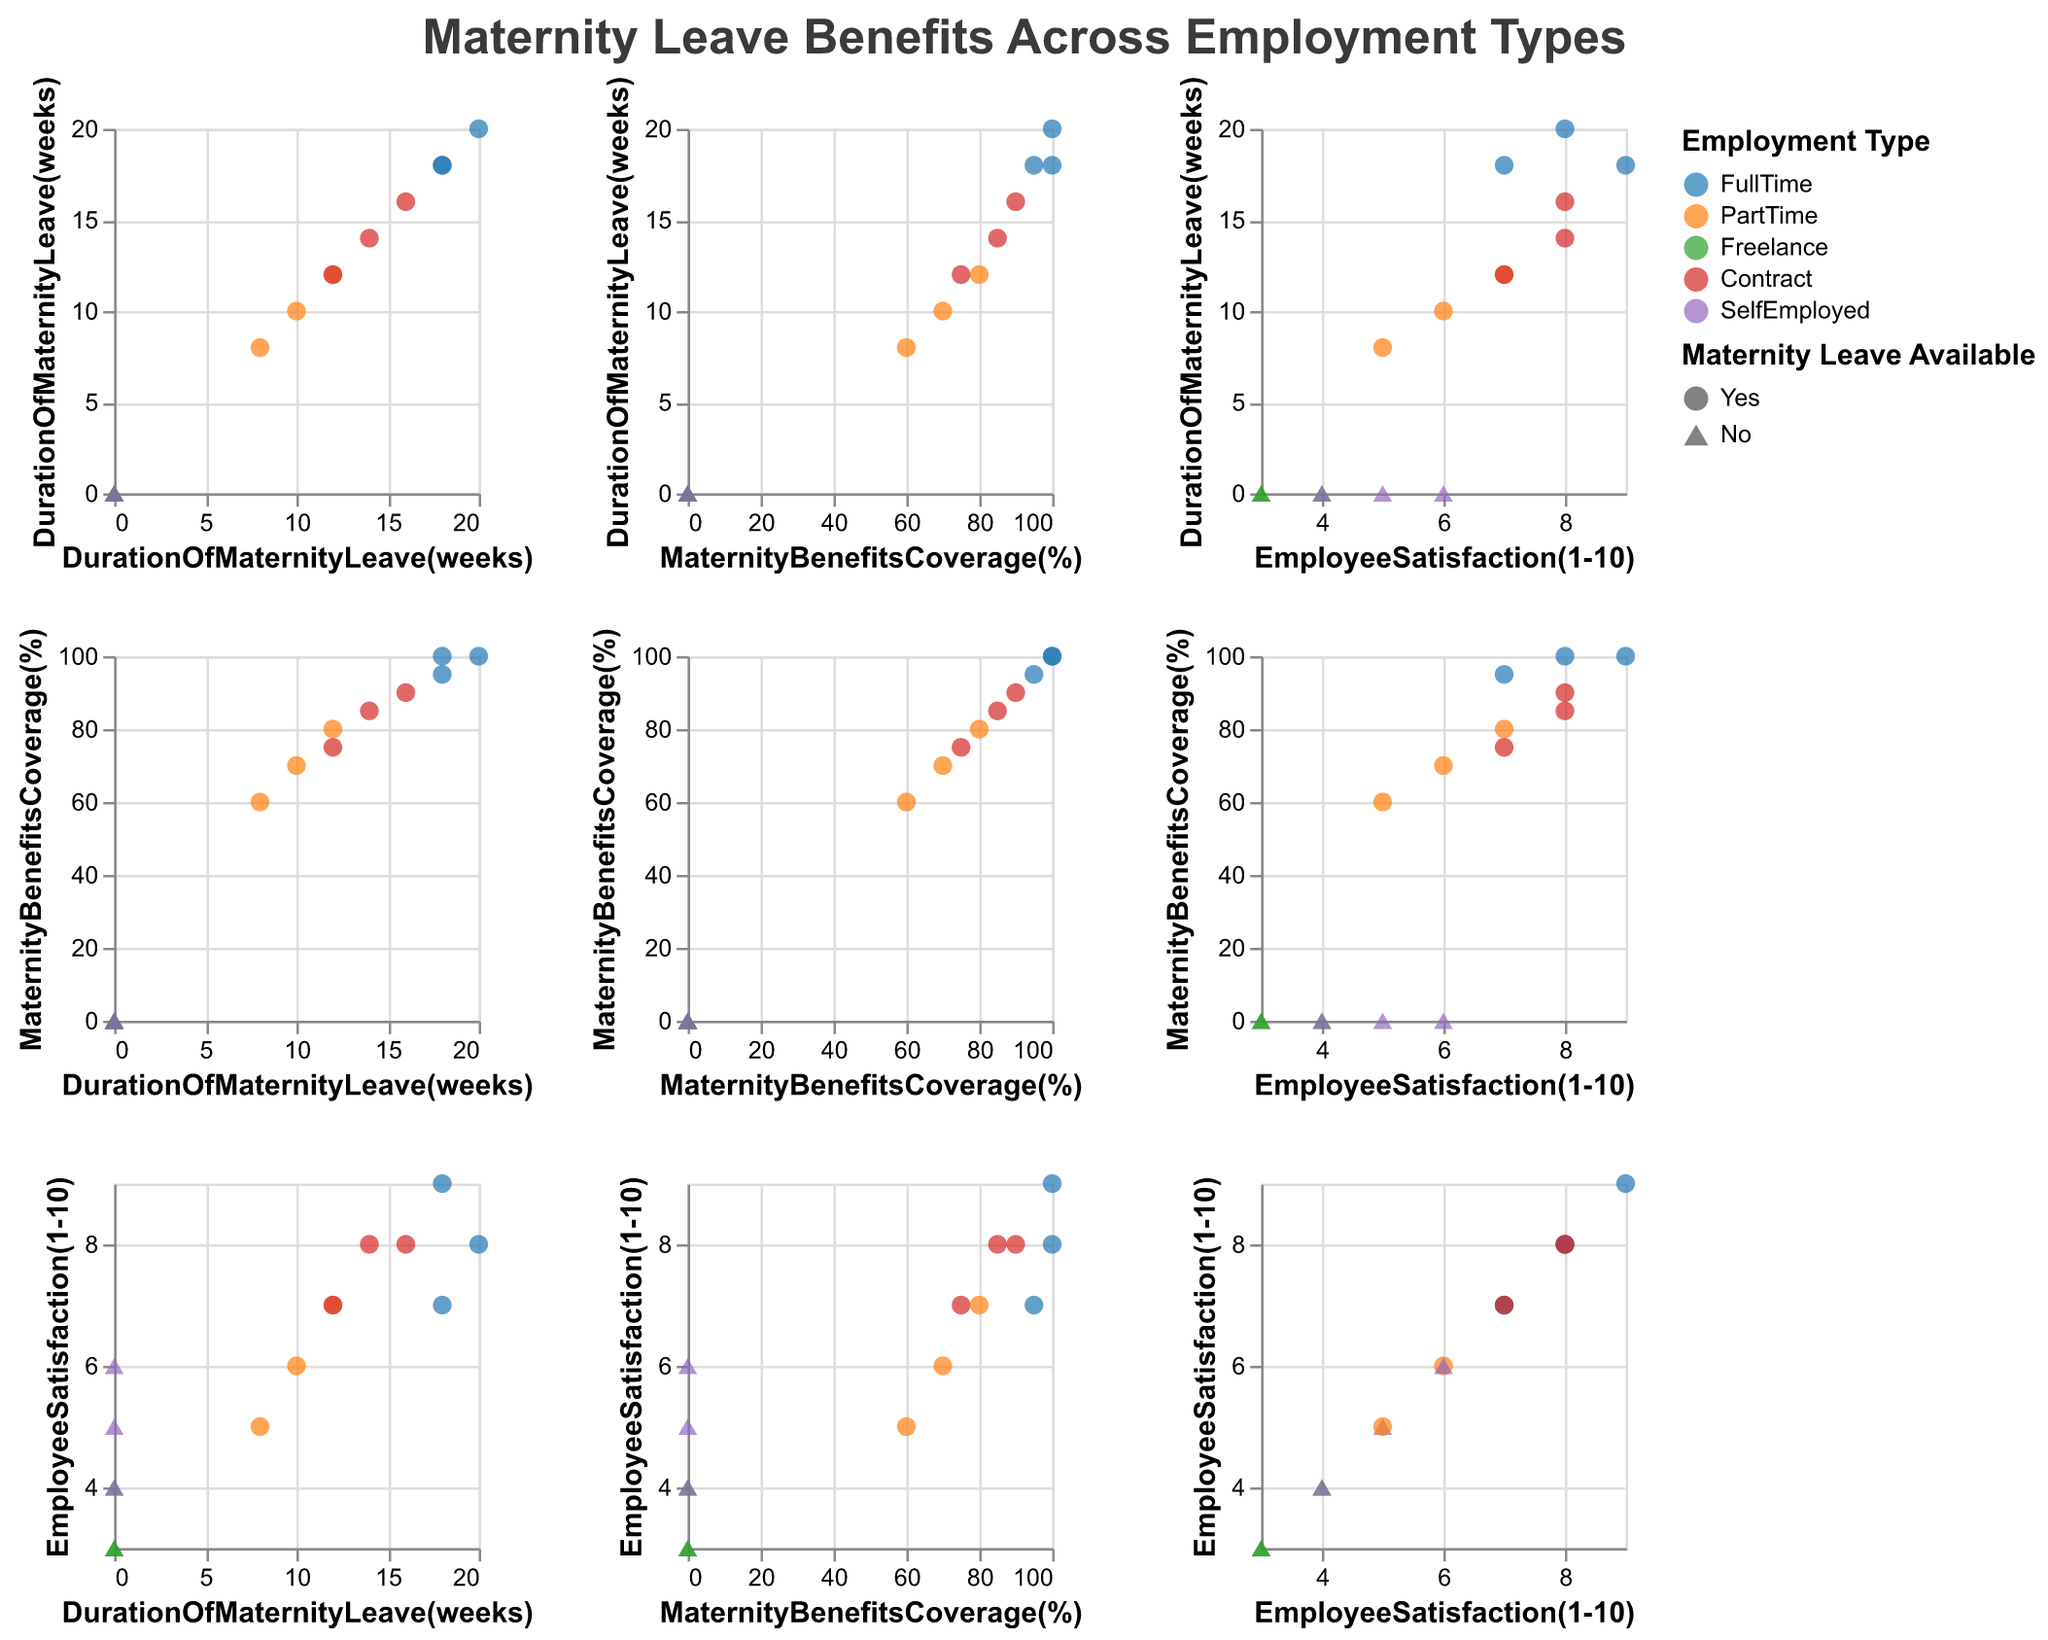What is the title of the figure? The title of the figure is displayed at the top and reads "Maternity Leave Benefits Across Employment Types".
Answer: Maternity Leave Benefits Across Employment Types Which employment type has the least availability of maternity leave? By looking at the shapes in the plot, triangles indicate the unavailability of maternity leave. Freelance and SelfEmployed both show only triangles.
Answer: Freelance and SelfEmployed What shape is used to indicate the availability of maternity leave? In the figure, a legend shows that circles indicate 'Yes' for availability of maternity leave.
Answer: Circle How many companies offer 100% maternity benefits coverage? By counting the data points at 100% on the y-axis "MaternityBenefitsCoverage(%)", there are two companies.
Answer: 2 Which company offers the longest duration of maternity leave? Identify the highest value on the "DurationOfMaternityLeave(weeks)" axis and check the tooltip for the company name. Amazon offers 20 weeks of maternity leave.
Answer: Amazon Is there a correlation between the duration of maternity leave and employee satisfaction? Look for any pattern in the scatter plots where "DurationOfMaternityLeave(weeks)" is on one axis and "EmployeeSatisfaction(1-10)" is on the other. Higher durations typically show higher satisfaction.
Answer: Generally positive correlation For full-time employees, what is the range of maternity benefits coverage? By focusing on the color representing "FullTime" (blue) and the y-axis "MaternityBenefitsCoverage(%)", the range spans from about 95% to 100%.
Answer: 95% to 100% Compare the employee satisfaction for contract employees versus part-time employees. By comparing the shapes representing "Contract" (red) and "PartTime" (orange) on the scatter plots for "EmployeeSatisfaction(1-10)", contract employees generally show higher satisfaction.
Answer: Contract employees generally higher On average, which employment type has the shortest duration of maternity leave? Calculate the average duration for each employment type. Freelancers, self-employed lack maternity leave, so their average is 0 weeks.
Answer: Freelance and SelfEmployed Does any self-employed company offer maternity benefits coverage? Check the shape of data points for self-employed (color purple) under "MaternityBenefitsCoverage(%)" for any coverage value greater than 0. There are none.
Answer: No 